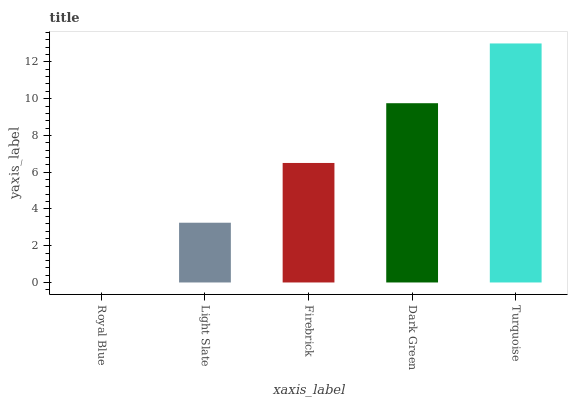Is Light Slate the minimum?
Answer yes or no. No. Is Light Slate the maximum?
Answer yes or no. No. Is Light Slate greater than Royal Blue?
Answer yes or no. Yes. Is Royal Blue less than Light Slate?
Answer yes or no. Yes. Is Royal Blue greater than Light Slate?
Answer yes or no. No. Is Light Slate less than Royal Blue?
Answer yes or no. No. Is Firebrick the high median?
Answer yes or no. Yes. Is Firebrick the low median?
Answer yes or no. Yes. Is Light Slate the high median?
Answer yes or no. No. Is Dark Green the low median?
Answer yes or no. No. 